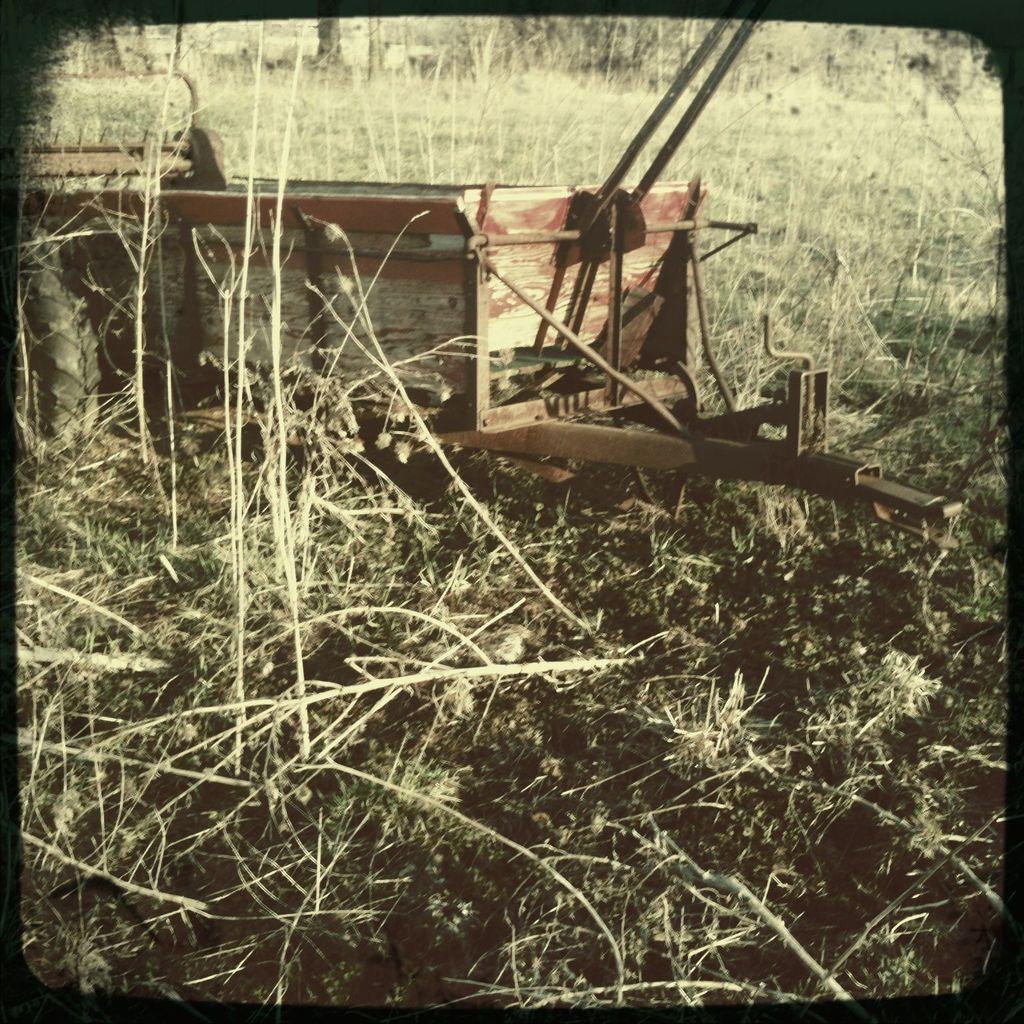Can you describe this image briefly? In this picture we can observe a truck placed on the ground. We can observe some plants on the ground. In the background there are trees and an open land. 